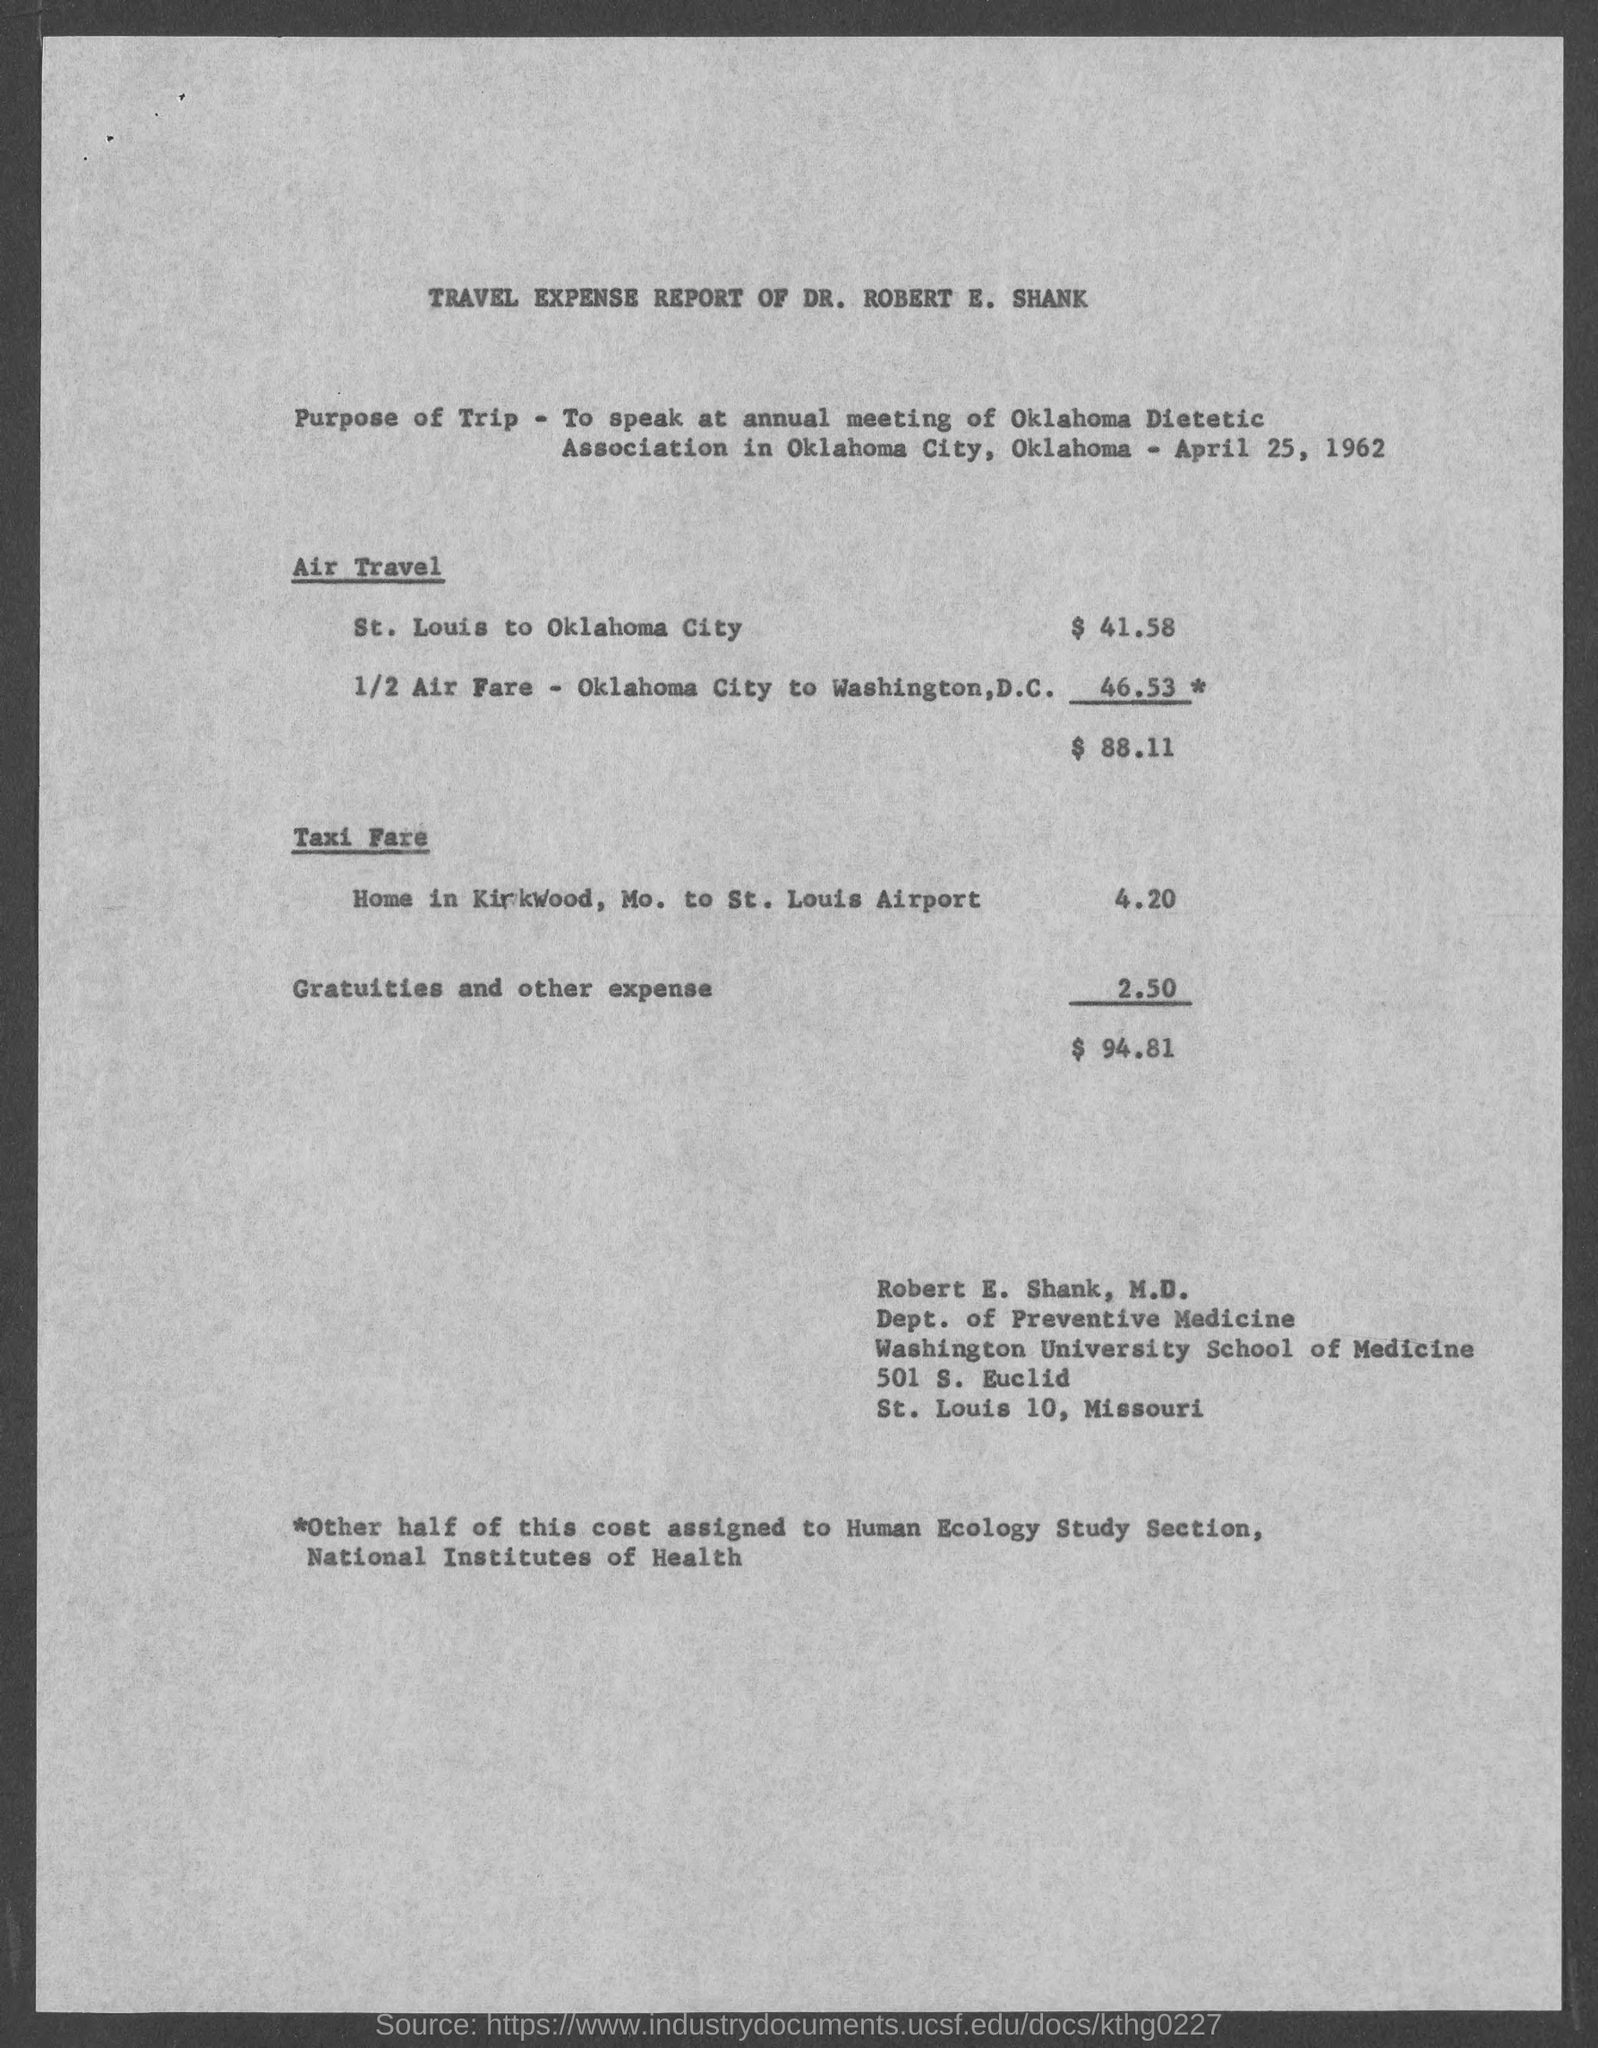What is the document about?
Keep it short and to the point. Travel Expense Report of Dr. Robert E. Shank. At which annual meeting did Dr. Robert speak?
Your answer should be very brief. Annual meeting of oklahoma dietetic association. When was the meeting held?
Your answer should be compact. April 25, 1962. What is the air travel expense from St. Louis to Oklahoma City?
Ensure brevity in your answer.  $ 41.58. 